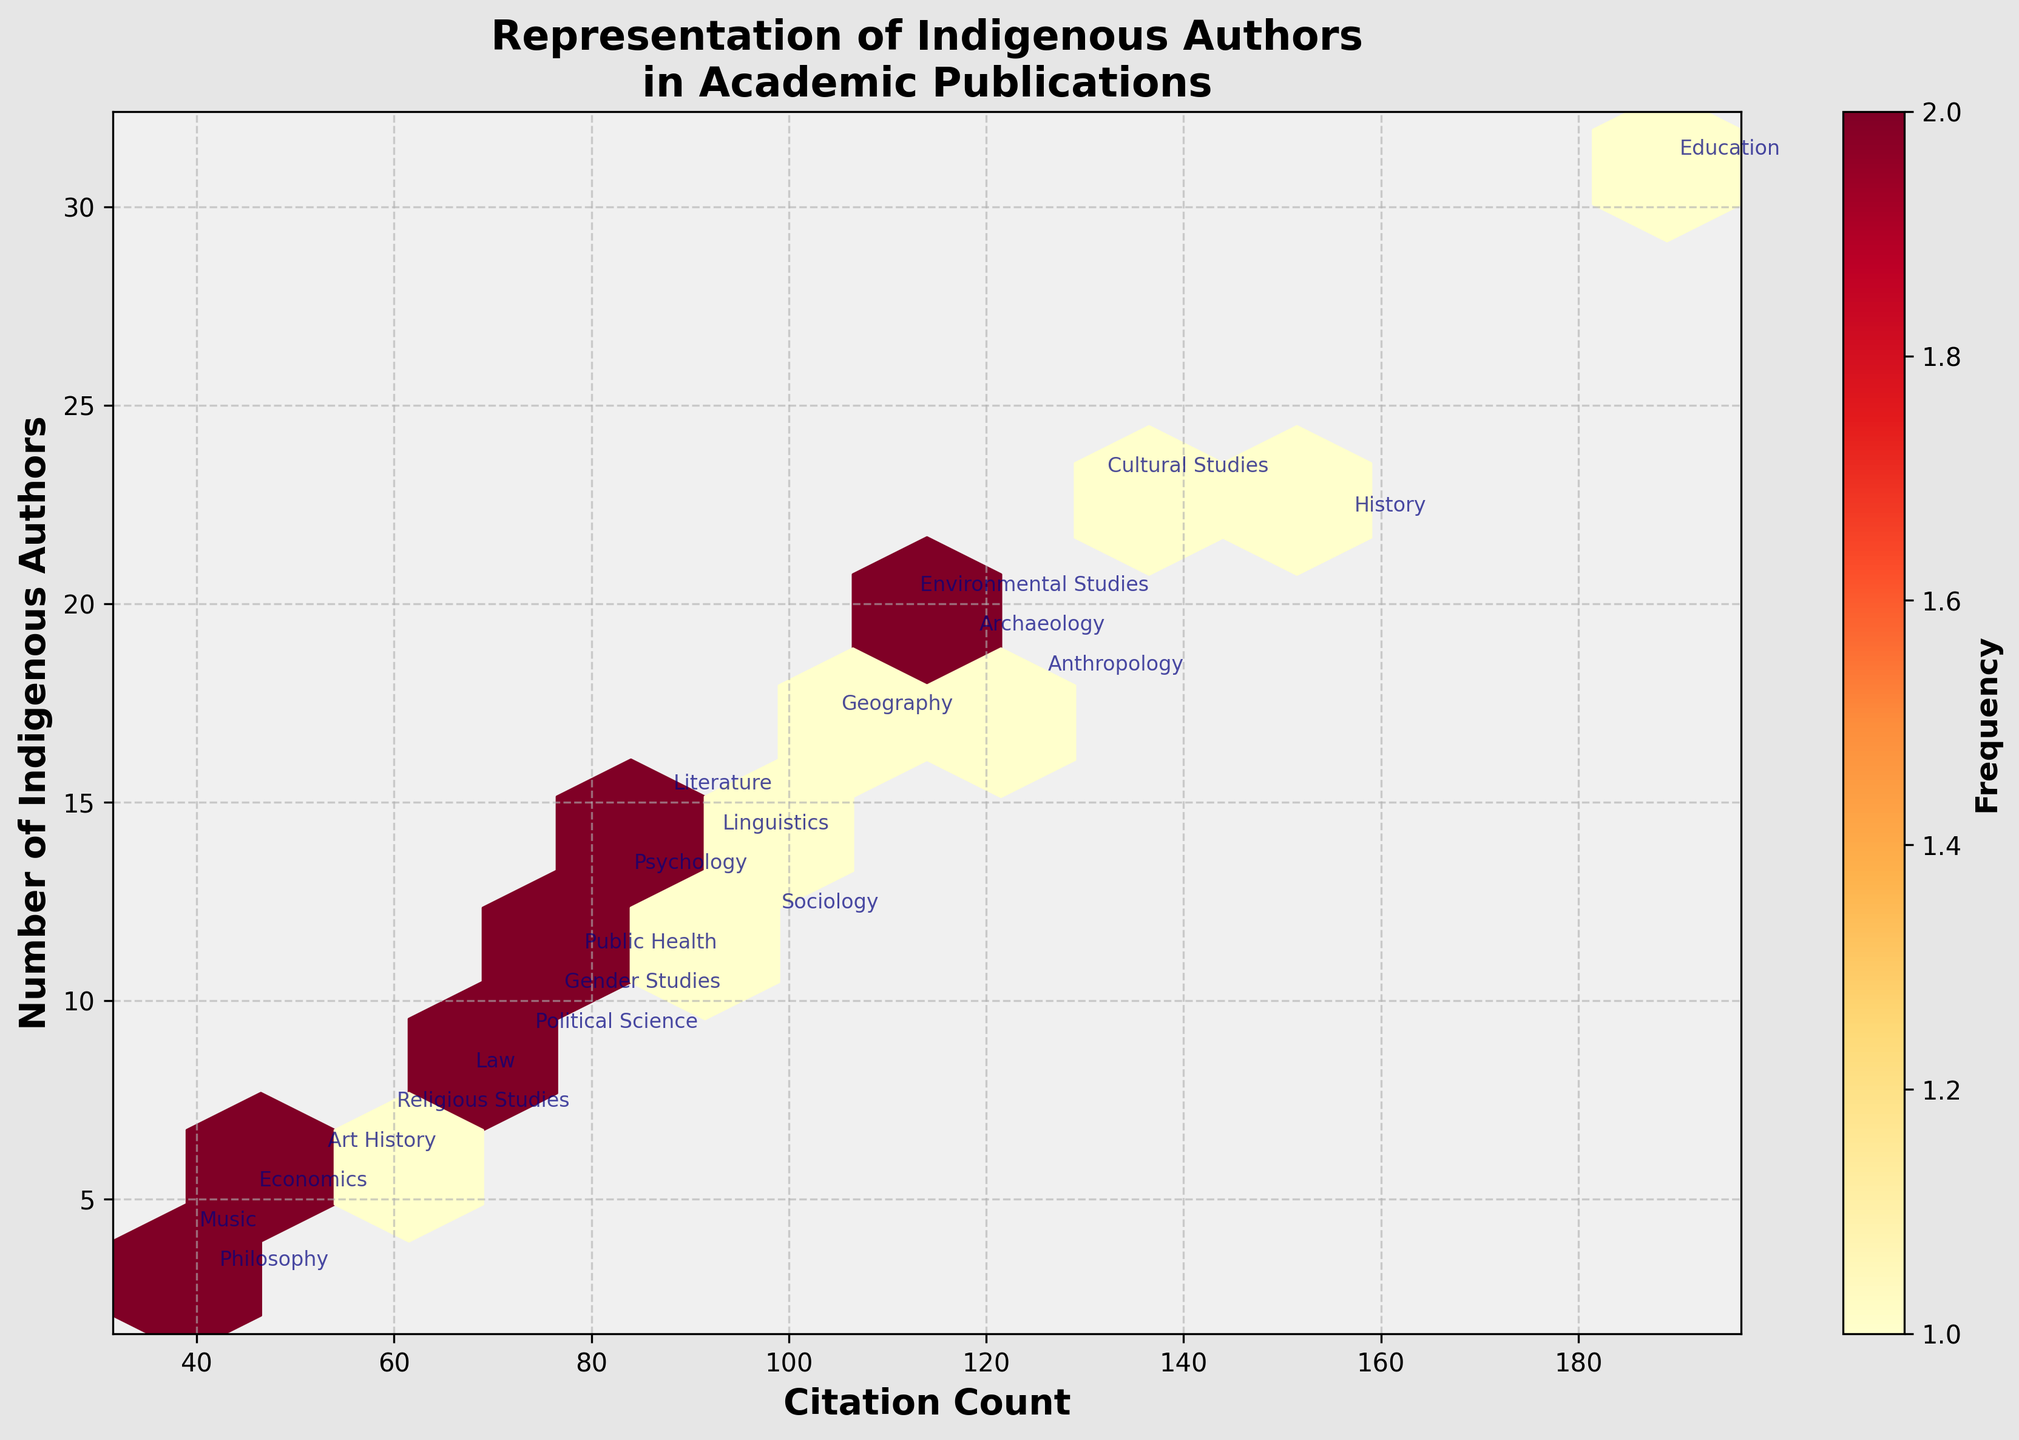What is the title of the figure? The title of the figure is displayed at the top and it typically summarizes the main focus of the figure. In this case, the title is "Representation of Indigenous Authors in Academic Publications".
Answer: Representation of Indigenous Authors in Academic Publications What are the labels of the X and Y axes? The labels for the axes represent the data plotted and are often found along the respective axes. Here, the X-axis is labeled "Citation Count" and the Y-axis is labeled "Number of Indigenous Authors".
Answer: Citation Count; Number of Indigenous Authors What color represents the highest frequency in the hexbin plot? The color of the hexagons indicates the frequency of data points within those bins, with the color scale shown by the colorbar. In this figure, the color representing the highest frequency is a darker shade of red, according to the 'YlOrRd' colormap used.
Answer: Dark red Which field of study has the highest number of Indigenous Authors? To identify the field with the highest number of Indigenous Authors, look for the highest Y-coordinate point labeled with a field name. Education appears at the highest Y-coordinate, which is 31.
Answer: Education Does Anthropology have more citations than History? By comparing the positions of Anthropology and History along the X-axis (Citation Count), it is evident that History has more citations (156) compared to Anthropology (125).
Answer: No Are there more Indigenous Authors in Cultural Studies or Sociology? To determine this, compare the Y-axis values of Cultural Studies (23) and Sociology (12). Cultural Studies has a higher Y-axis value, indicating more Indigenous Authors.
Answer: Cultural Studies Which two fields of study appear most frequently in the bin with the highest number of Indigenous Authors? Locate the highest Y-coordinate on the Y-axis, corresponding to the highest number of Indigenous Authors (31). Identify which fields of study are annotated in the hexbins around that position. Education appears most frequently in this bin.
Answer: Education What is the range of Citation Counts for fields with Indigenous Authors between 10 and 20? Look for fields annotated vertically between 10 and 20 on the Y-axis and then note their positions on the X-axis. The corresponding Citation Counts range from 41 to 131 (Philosophy to Anthropology).
Answer: 41 to 131 Which field of study has the least number of Indigenous Authors and how many are there? Locate the lowest Y-coordinate on the Y-axis that has a text annotation. Philosophy appears at the lowest Y-coordinate with 3 Indigenous Authors.
Answer: Philosophy; 3 